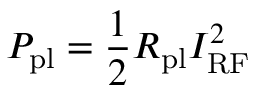Convert formula to latex. <formula><loc_0><loc_0><loc_500><loc_500>P _ { p l } = \frac { 1 } { 2 } R _ { p l } I _ { R F } ^ { 2 }</formula> 